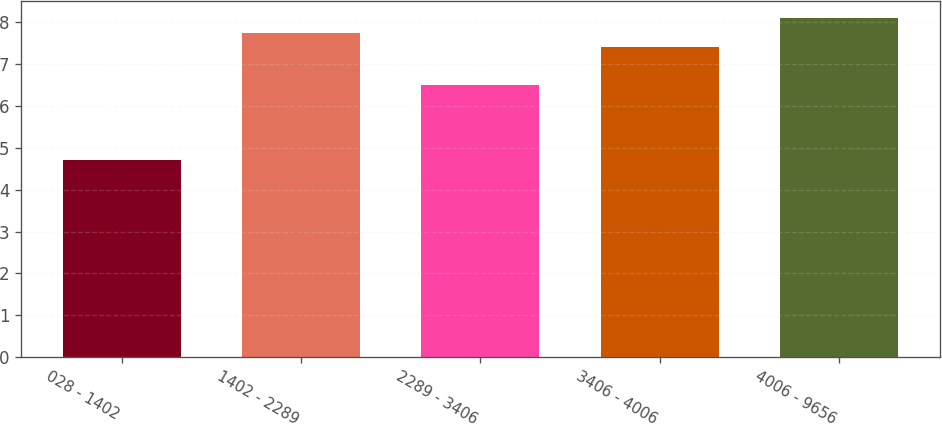Convert chart. <chart><loc_0><loc_0><loc_500><loc_500><bar_chart><fcel>028 - 1402<fcel>1402 - 2289<fcel>2289 - 3406<fcel>3406 - 4006<fcel>4006 - 9656<nl><fcel>4.7<fcel>7.74<fcel>6.5<fcel>7.4<fcel>8.1<nl></chart> 